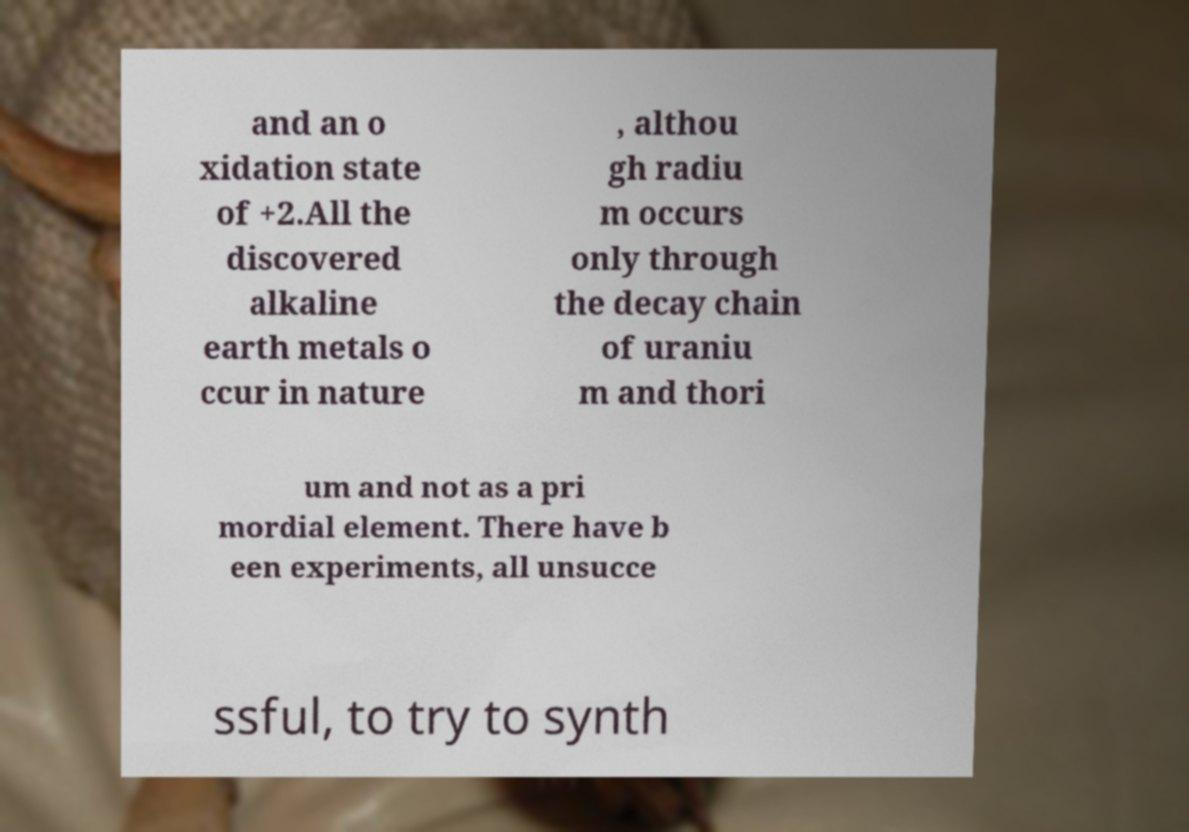Can you read and provide the text displayed in the image?This photo seems to have some interesting text. Can you extract and type it out for me? and an o xidation state of +2.All the discovered alkaline earth metals o ccur in nature , althou gh radiu m occurs only through the decay chain of uraniu m and thori um and not as a pri mordial element. There have b een experiments, all unsucce ssful, to try to synth 